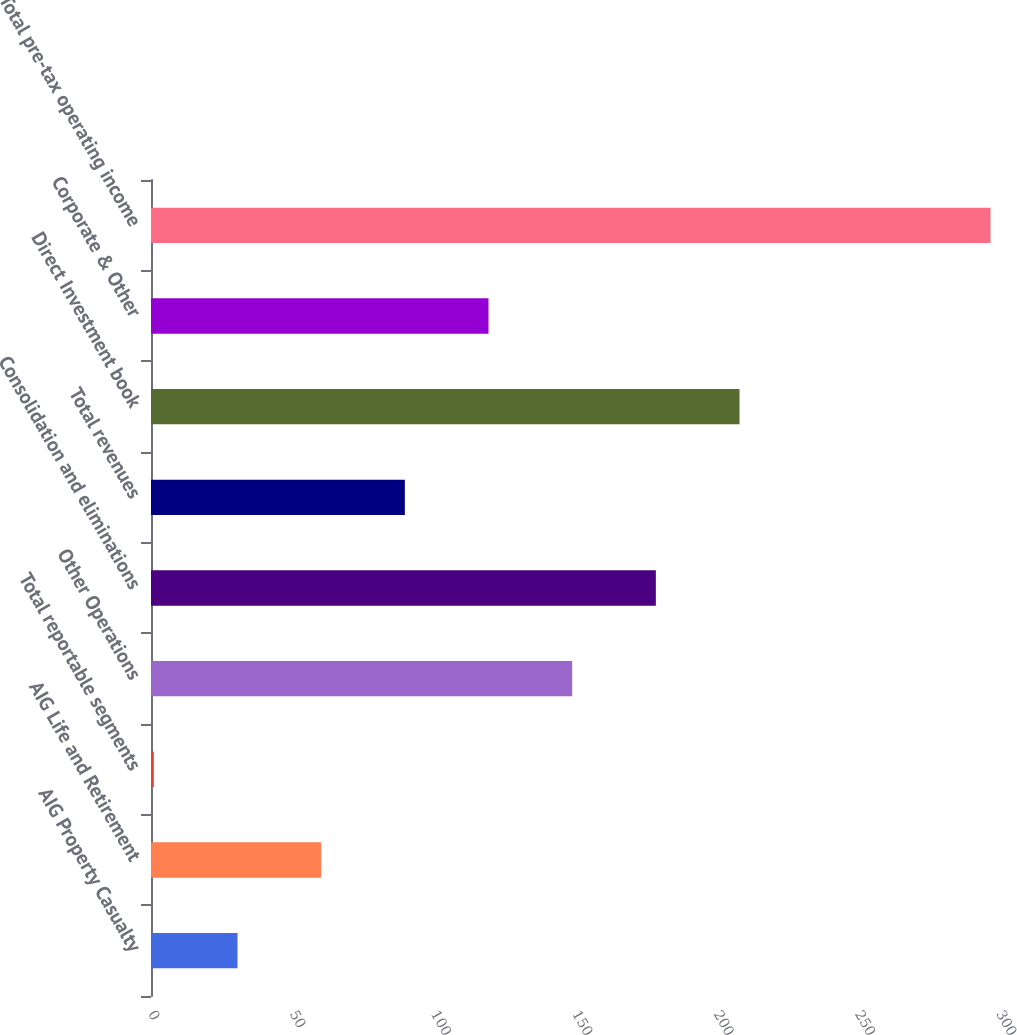<chart> <loc_0><loc_0><loc_500><loc_500><bar_chart><fcel>AIG Property Casualty<fcel>AIG Life and Retirement<fcel>Total reportable segments<fcel>Other Operations<fcel>Consolidation and eliminations<fcel>Total revenues<fcel>Direct Investment book<fcel>Corporate & Other<fcel>Total pre-tax operating income<nl><fcel>30.6<fcel>60.2<fcel>1<fcel>149<fcel>178.6<fcel>89.8<fcel>208.2<fcel>119.4<fcel>297<nl></chart> 